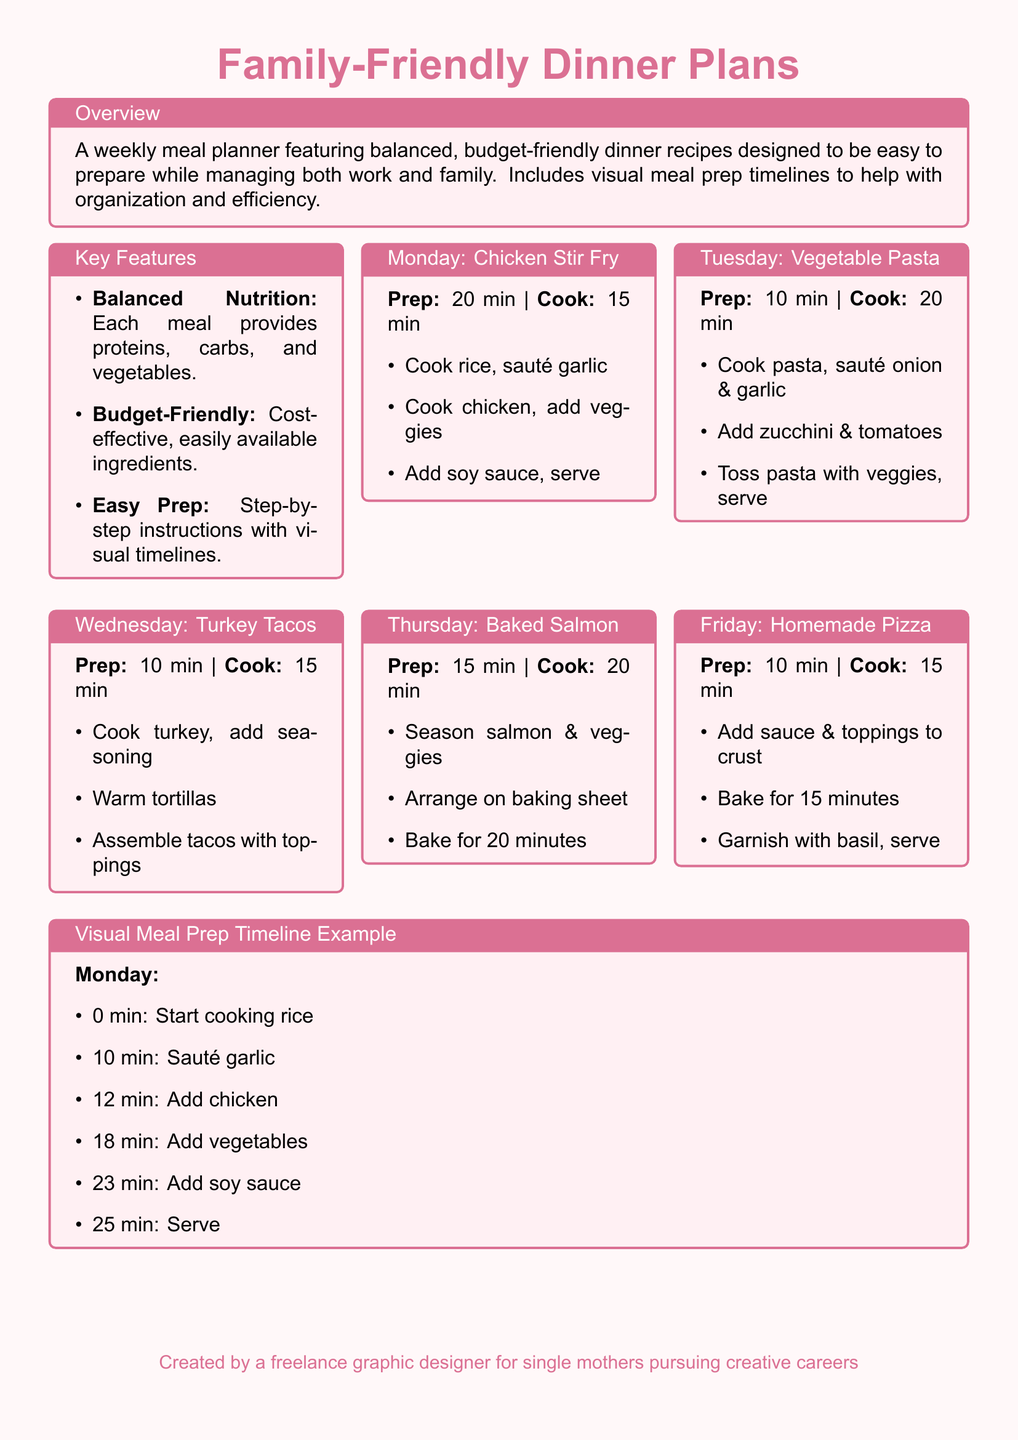What is the title of the document? The title is presented prominently at the top of the document, indicating the main subject of the content.
Answer: Family-Friendly Dinner Plans How many minutes does it take to prepare the Vegetable Pasta? The preparation time for the Vegetable Pasta is clearly stated in its respective box.
Answer: 10 min What type of meal is featured for Wednesday? The meal type for Wednesday is explicitly mentioned within that day's section.
Answer: Turkey Tacos What is the prep time for Baked Salmon? The prep time for Baked Salmon is listed under the title for that meal.
Answer: 15 min How long does the Homemade Pizza take to cook? The cooking time for Homemade Pizza is provided in the meal preparation section.
Answer: 15 min What is the key feature related to budget? The key feature acknowledges the financial aspect focusing on ingredient costs.
Answer: Budget-Friendly How many meals are planned for the week in the document? The document outlines meal plans for each day from Monday to Friday, indicating the total.
Answer: 5 What is the cooking time for Chicken Stir Fry? The cooking time is specified alongside the preparation details for Chicken Stir Fry.
Answer: 15 min What color is used for the document's background? The background color is mentioned in the layout details of the document.
Answer: Light pink 